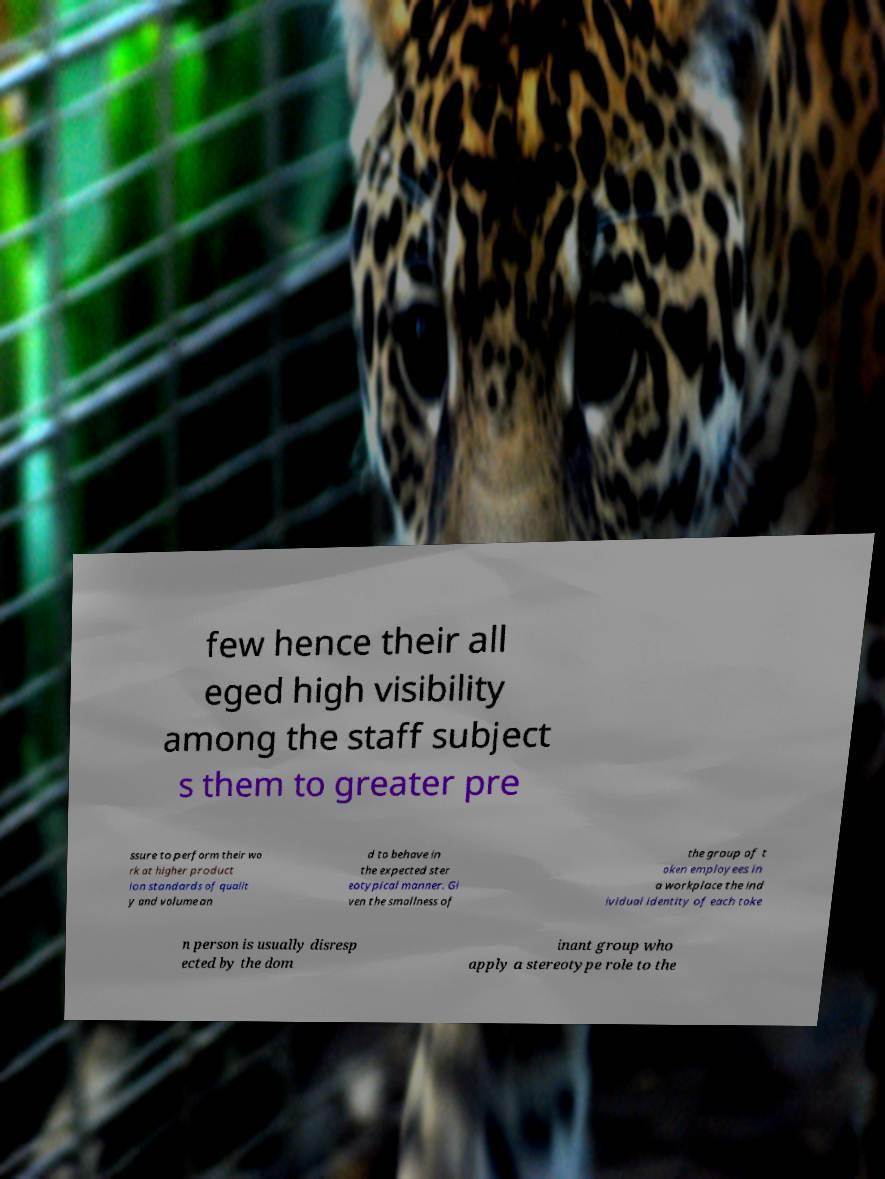What messages or text are displayed in this image? I need them in a readable, typed format. few hence their all eged high visibility among the staff subject s them to greater pre ssure to perform their wo rk at higher product ion standards of qualit y and volume an d to behave in the expected ster eotypical manner. Gi ven the smallness of the group of t oken employees in a workplace the ind ividual identity of each toke n person is usually disresp ected by the dom inant group who apply a stereotype role to the 